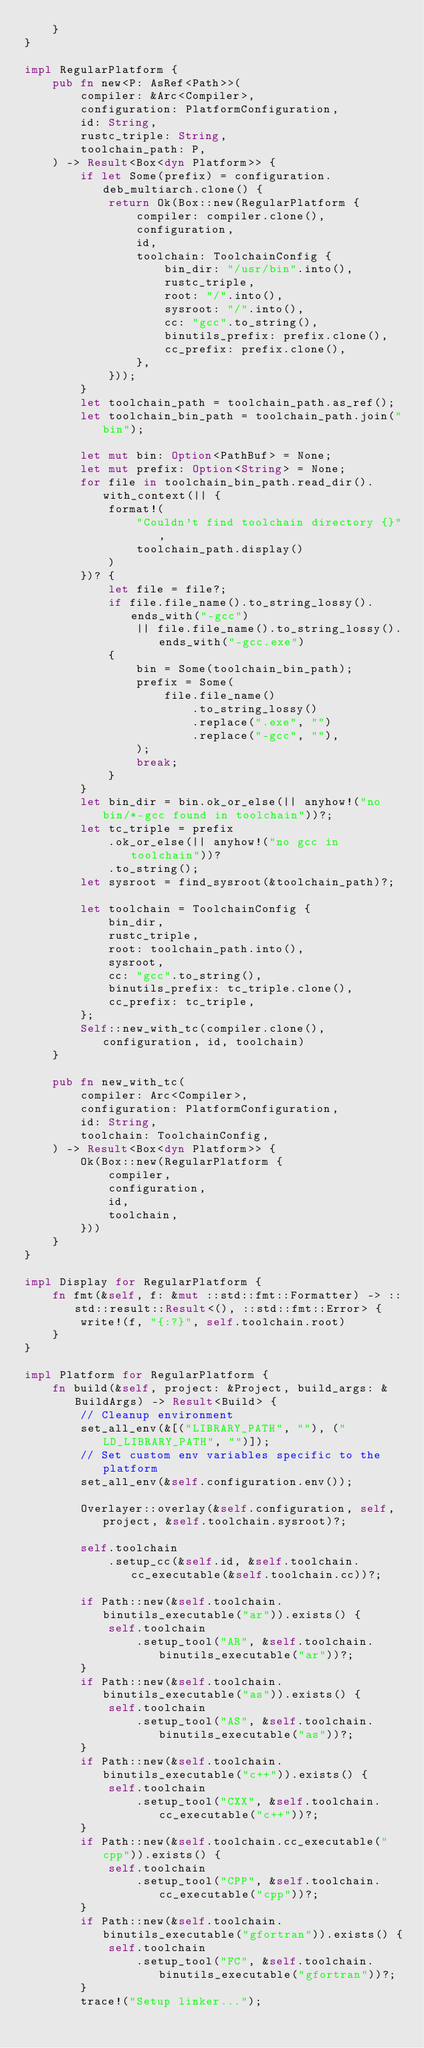Convert code to text. <code><loc_0><loc_0><loc_500><loc_500><_Rust_>    }
}

impl RegularPlatform {
    pub fn new<P: AsRef<Path>>(
        compiler: &Arc<Compiler>,
        configuration: PlatformConfiguration,
        id: String,
        rustc_triple: String,
        toolchain_path: P,
    ) -> Result<Box<dyn Platform>> {
        if let Some(prefix) = configuration.deb_multiarch.clone() {
            return Ok(Box::new(RegularPlatform {
                compiler: compiler.clone(),
                configuration,
                id,
                toolchain: ToolchainConfig {
                    bin_dir: "/usr/bin".into(),
                    rustc_triple,
                    root: "/".into(),
                    sysroot: "/".into(),
                    cc: "gcc".to_string(),
                    binutils_prefix: prefix.clone(),
                    cc_prefix: prefix.clone(),
                },
            }));
        }
        let toolchain_path = toolchain_path.as_ref();
        let toolchain_bin_path = toolchain_path.join("bin");

        let mut bin: Option<PathBuf> = None;
        let mut prefix: Option<String> = None;
        for file in toolchain_bin_path.read_dir().with_context(|| {
            format!(
                "Couldn't find toolchain directory {}",
                toolchain_path.display()
            )
        })? {
            let file = file?;
            if file.file_name().to_string_lossy().ends_with("-gcc")
                || file.file_name().to_string_lossy().ends_with("-gcc.exe")
            {
                bin = Some(toolchain_bin_path);
                prefix = Some(
                    file.file_name()
                        .to_string_lossy()
                        .replace(".exe", "")
                        .replace("-gcc", ""),
                );
                break;
            }
        }
        let bin_dir = bin.ok_or_else(|| anyhow!("no bin/*-gcc found in toolchain"))?;
        let tc_triple = prefix
            .ok_or_else(|| anyhow!("no gcc in toolchain"))?
            .to_string();
        let sysroot = find_sysroot(&toolchain_path)?;

        let toolchain = ToolchainConfig {
            bin_dir,
            rustc_triple,
            root: toolchain_path.into(),
            sysroot,
            cc: "gcc".to_string(),
            binutils_prefix: tc_triple.clone(),
            cc_prefix: tc_triple,
        };
        Self::new_with_tc(compiler.clone(), configuration, id, toolchain)
    }

    pub fn new_with_tc(
        compiler: Arc<Compiler>,
        configuration: PlatformConfiguration,
        id: String,
        toolchain: ToolchainConfig,
    ) -> Result<Box<dyn Platform>> {
        Ok(Box::new(RegularPlatform {
            compiler,
            configuration,
            id,
            toolchain,
        }))
    }
}

impl Display for RegularPlatform {
    fn fmt(&self, f: &mut ::std::fmt::Formatter) -> ::std::result::Result<(), ::std::fmt::Error> {
        write!(f, "{:?}", self.toolchain.root)
    }
}

impl Platform for RegularPlatform {
    fn build(&self, project: &Project, build_args: &BuildArgs) -> Result<Build> {
        // Cleanup environment
        set_all_env(&[("LIBRARY_PATH", ""), ("LD_LIBRARY_PATH", "")]);
        // Set custom env variables specific to the platform
        set_all_env(&self.configuration.env());

        Overlayer::overlay(&self.configuration, self, project, &self.toolchain.sysroot)?;

        self.toolchain
            .setup_cc(&self.id, &self.toolchain.cc_executable(&self.toolchain.cc))?;

        if Path::new(&self.toolchain.binutils_executable("ar")).exists() {
            self.toolchain
                .setup_tool("AR", &self.toolchain.binutils_executable("ar"))?;
        }
        if Path::new(&self.toolchain.binutils_executable("as")).exists() {
            self.toolchain
                .setup_tool("AS", &self.toolchain.binutils_executable("as"))?;
        }
        if Path::new(&self.toolchain.binutils_executable("c++")).exists() {
            self.toolchain
                .setup_tool("CXX", &self.toolchain.cc_executable("c++"))?;
        }
        if Path::new(&self.toolchain.cc_executable("cpp")).exists() {
            self.toolchain
                .setup_tool("CPP", &self.toolchain.cc_executable("cpp"))?;
        }
        if Path::new(&self.toolchain.binutils_executable("gfortran")).exists() {
            self.toolchain
                .setup_tool("FC", &self.toolchain.binutils_executable("gfortran"))?;
        }
        trace!("Setup linker...");
</code> 